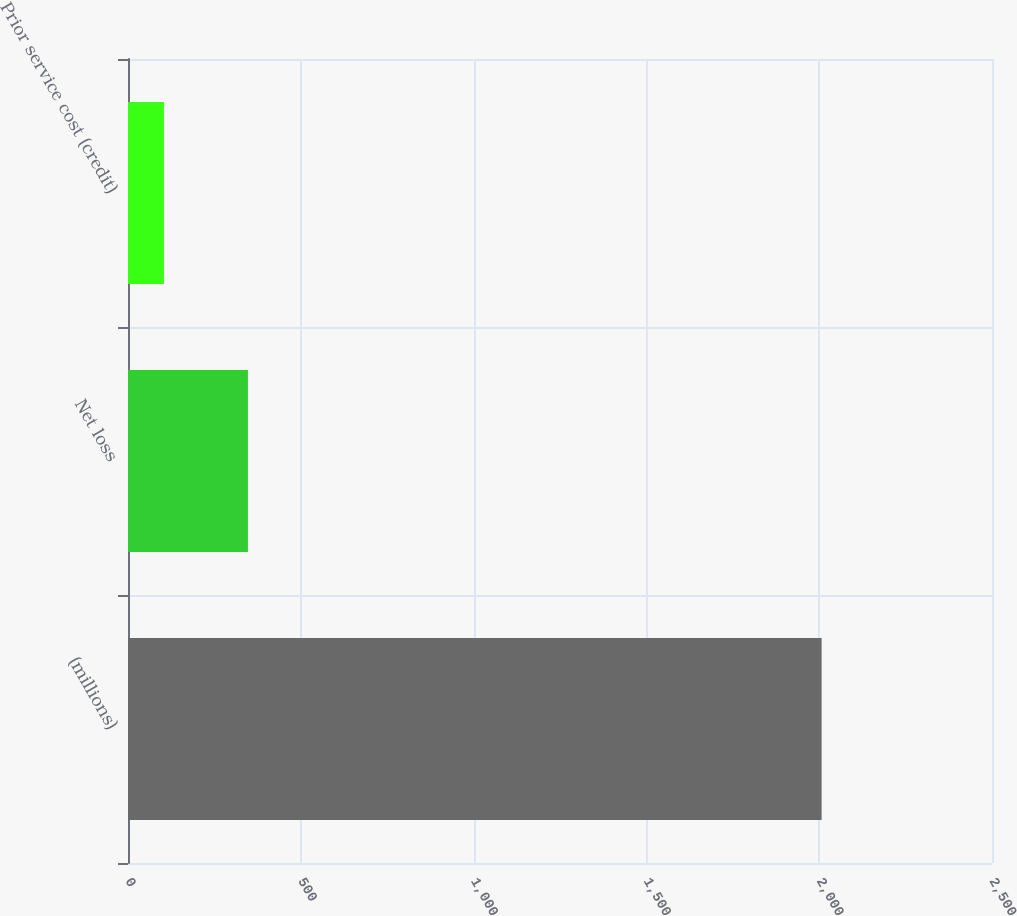Convert chart. <chart><loc_0><loc_0><loc_500><loc_500><bar_chart><fcel>(millions)<fcel>Net loss<fcel>Prior service cost (credit)<nl><fcel>2007<fcel>347<fcel>104<nl></chart> 